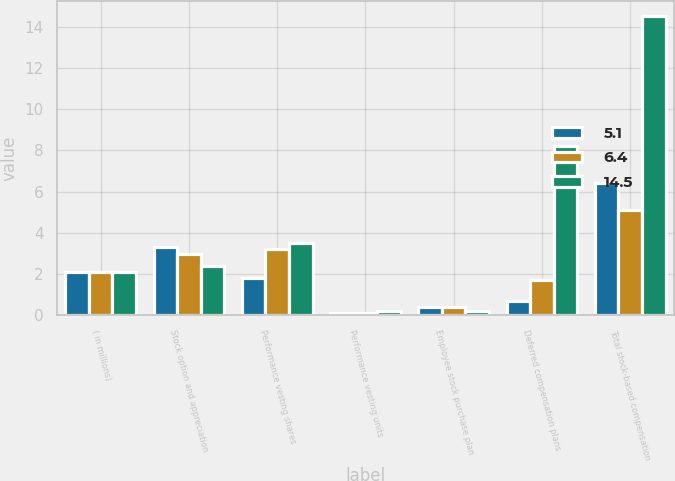Convert chart. <chart><loc_0><loc_0><loc_500><loc_500><stacked_bar_chart><ecel><fcel>( in millions)<fcel>Stock option and appreciation<fcel>Performance vesting shares<fcel>Performance vesting units<fcel>Employee stock purchase plan<fcel>Deferred compensation plans<fcel>Total stock-based compensation<nl><fcel>5.1<fcel>2.1<fcel>3.3<fcel>1.8<fcel>0.1<fcel>0.4<fcel>0.7<fcel>6.4<nl><fcel>6.4<fcel>2.1<fcel>3<fcel>3.2<fcel>0.1<fcel>0.4<fcel>1.7<fcel>5.1<nl><fcel>14.5<fcel>2.1<fcel>2.4<fcel>3.5<fcel>0.2<fcel>0.2<fcel>8.2<fcel>14.5<nl></chart> 